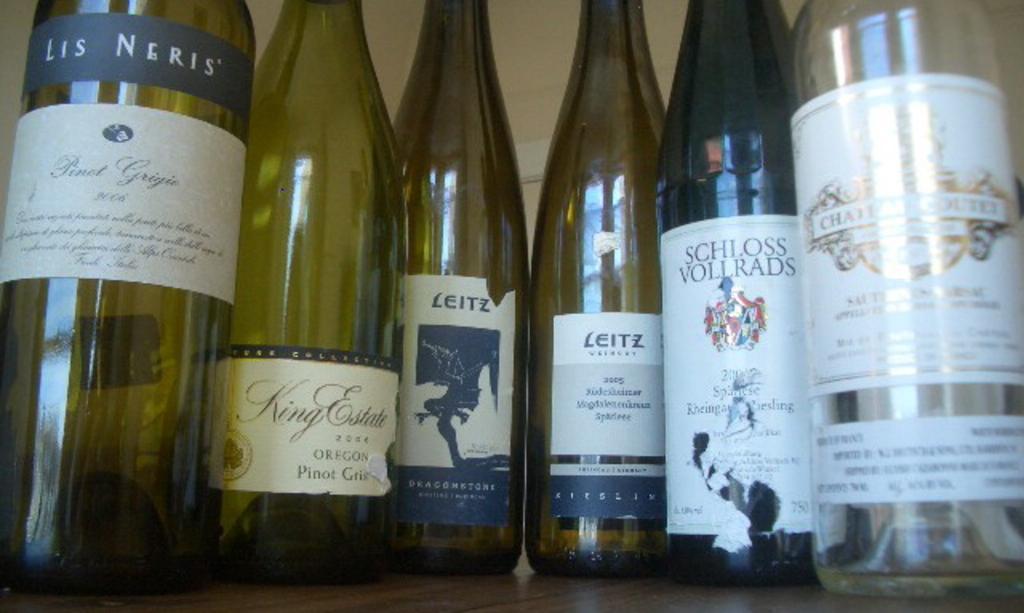Can you describe this image briefly? In this picture we can see some bottles are placed on that bottles there is a stickering in each and every bottle. 